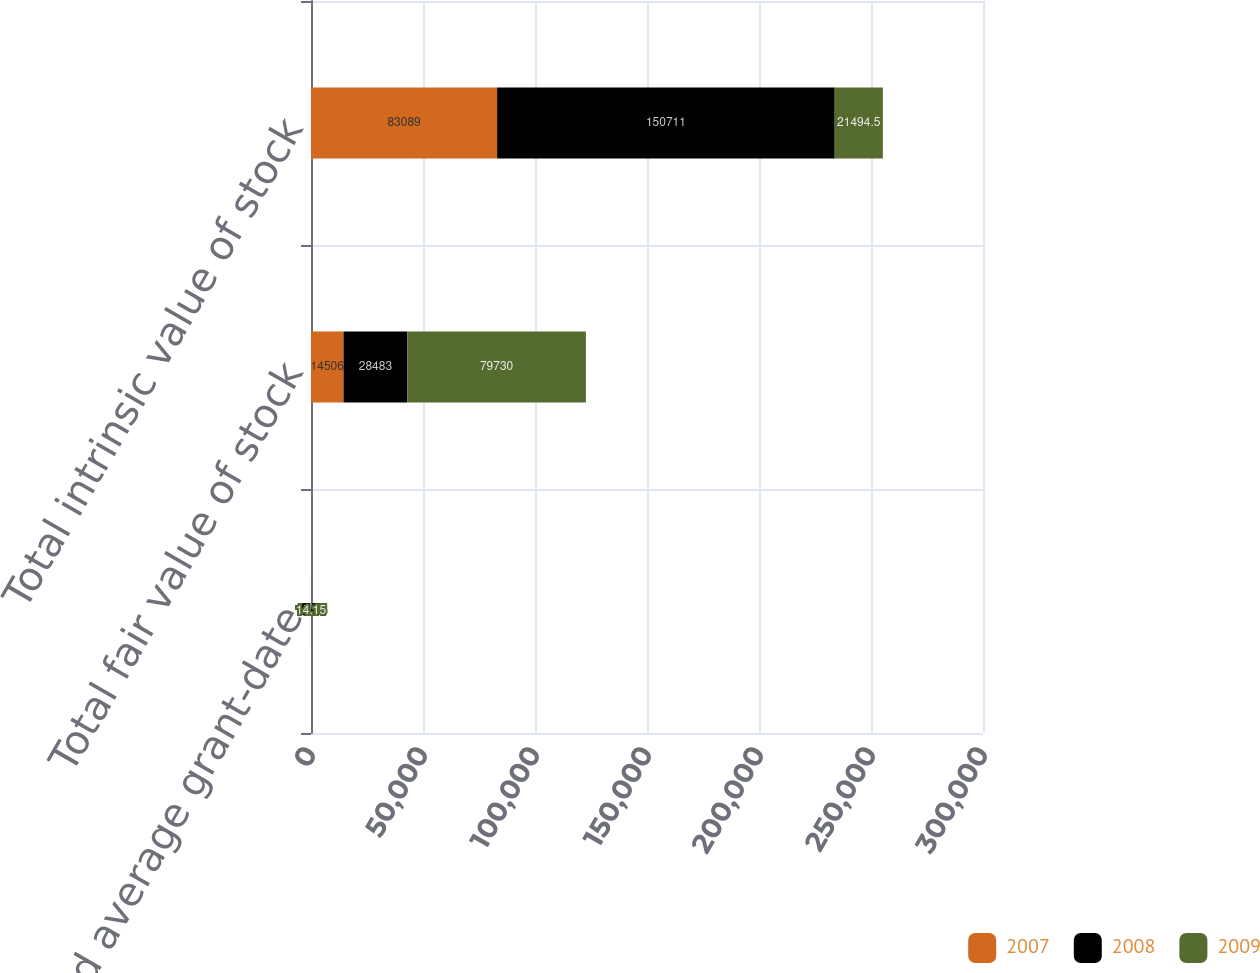<chart> <loc_0><loc_0><loc_500><loc_500><stacked_bar_chart><ecel><fcel>Weighted average grant-date<fcel>Total fair value of stock<fcel>Total intrinsic value of stock<nl><fcel>2007<fcel>12.54<fcel>14506<fcel>83089<nl><fcel>2008<fcel>15.51<fcel>28483<fcel>150711<nl><fcel>2009<fcel>14.15<fcel>79730<fcel>21494.5<nl></chart> 